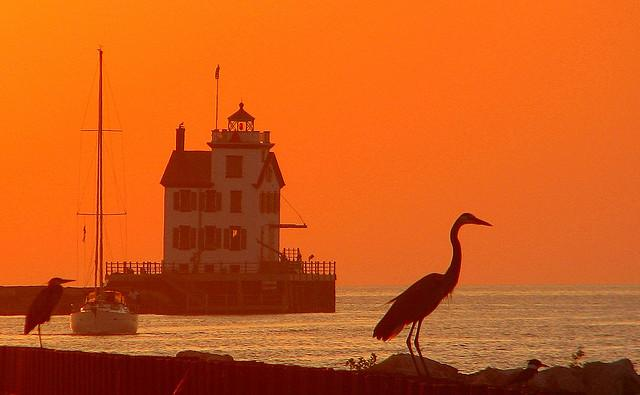Which animal is most similar to the animal on the right? Please explain your reasoning. egret. They are both birds 